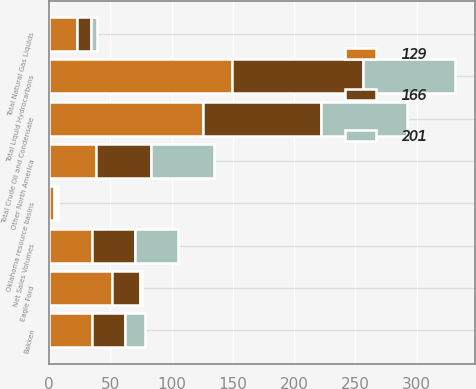Convert chart to OTSL. <chart><loc_0><loc_0><loc_500><loc_500><stacked_bar_chart><ecel><fcel>Net Sales Volumes<fcel>Bakken<fcel>Eagle Ford<fcel>Other North America<fcel>Total Crude Oil and Condensate<fcel>Oklahoma resource basins<fcel>Total Natural Gas Liquids<fcel>Total Liquid Hydrocarbons<nl><fcel>129<fcel>35<fcel>35<fcel>51<fcel>38<fcel>126<fcel>4<fcel>23<fcel>149<nl><fcel>166<fcel>35<fcel>27<fcel>23<fcel>45<fcel>96<fcel>2<fcel>11<fcel>107<nl><fcel>201<fcel>35<fcel>16<fcel>2<fcel>52<fcel>70<fcel>1<fcel>5<fcel>75<nl></chart> 